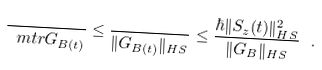<formula> <loc_0><loc_0><loc_500><loc_500>\frac { } { \ m t r G _ { B ( t ) } } \leq \frac { } { \| G _ { B ( t ) } \| _ { H S } } \leq \frac { \hbar { \| } S _ { z } ( t ) \| _ { H S } ^ { 2 } } { \| G _ { B } \| _ { H S } } \ .</formula> 